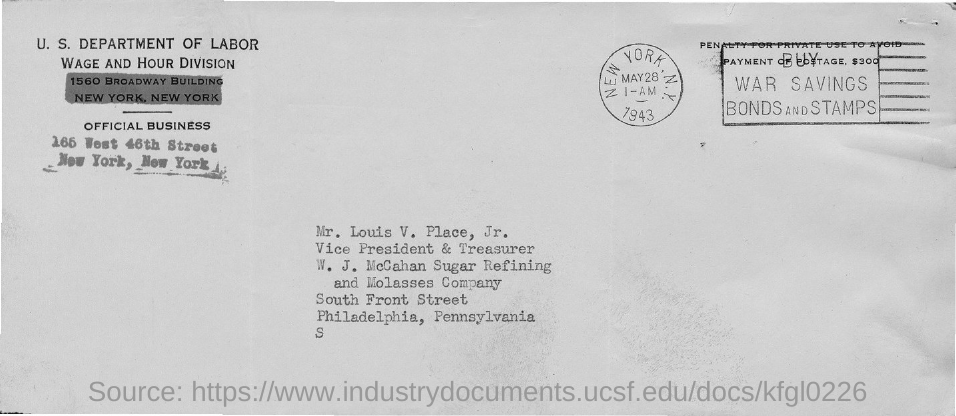What is the name of the person given in the address?
Give a very brief answer. Mr. Louis V. Place, Jr. 